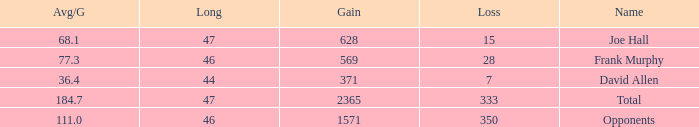Could you parse the entire table as a dict? {'header': ['Avg/G', 'Long', 'Gain', 'Loss', 'Name'], 'rows': [['68.1', '47', '628', '15', 'Joe Hall'], ['77.3', '46', '569', '28', 'Frank Murphy'], ['36.4', '44', '371', '7', 'David Allen'], ['184.7', '47', '2365', '333', 'Total'], ['111.0', '46', '1571', '350', 'Opponents']]} Which avg/g has a name of david allen, and a gain greater than 371? None. 